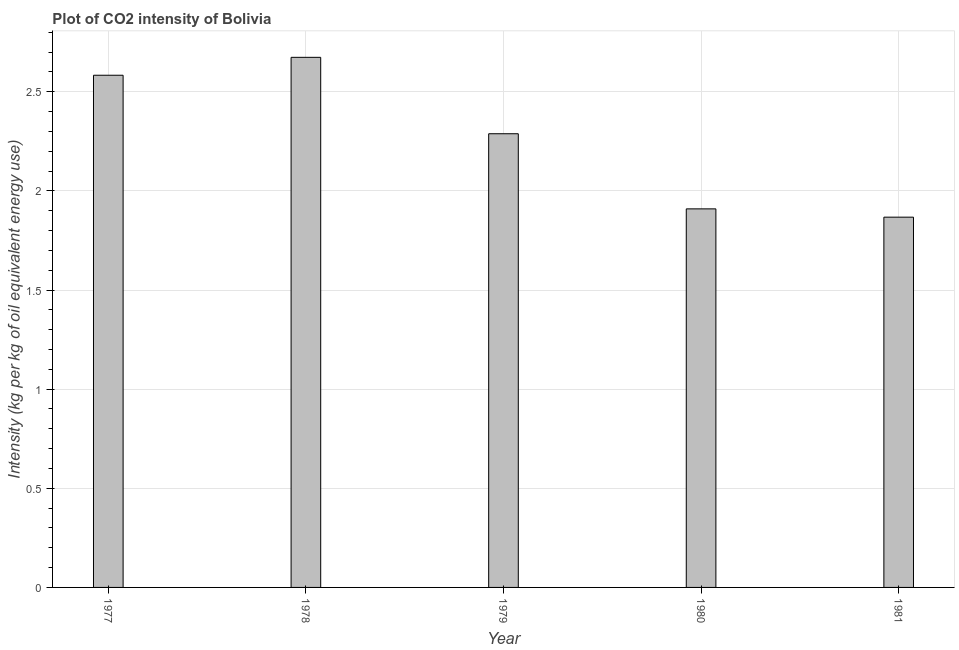Does the graph contain grids?
Offer a very short reply. Yes. What is the title of the graph?
Your response must be concise. Plot of CO2 intensity of Bolivia. What is the label or title of the X-axis?
Provide a succinct answer. Year. What is the label or title of the Y-axis?
Your response must be concise. Intensity (kg per kg of oil equivalent energy use). What is the co2 intensity in 1980?
Provide a succinct answer. 1.91. Across all years, what is the maximum co2 intensity?
Make the answer very short. 2.67. Across all years, what is the minimum co2 intensity?
Give a very brief answer. 1.87. In which year was the co2 intensity maximum?
Offer a very short reply. 1978. What is the sum of the co2 intensity?
Ensure brevity in your answer.  11.32. What is the difference between the co2 intensity in 1978 and 1979?
Your response must be concise. 0.39. What is the average co2 intensity per year?
Offer a terse response. 2.26. What is the median co2 intensity?
Offer a very short reply. 2.29. Do a majority of the years between 1980 and 1978 (inclusive) have co2 intensity greater than 1.6 kg?
Your response must be concise. Yes. What is the ratio of the co2 intensity in 1979 to that in 1980?
Your answer should be very brief. 1.2. Is the difference between the co2 intensity in 1977 and 1978 greater than the difference between any two years?
Provide a short and direct response. No. What is the difference between the highest and the second highest co2 intensity?
Offer a very short reply. 0.09. What is the difference between the highest and the lowest co2 intensity?
Your answer should be compact. 0.81. In how many years, is the co2 intensity greater than the average co2 intensity taken over all years?
Provide a succinct answer. 3. How many years are there in the graph?
Give a very brief answer. 5. What is the difference between two consecutive major ticks on the Y-axis?
Provide a succinct answer. 0.5. What is the Intensity (kg per kg of oil equivalent energy use) in 1977?
Provide a succinct answer. 2.58. What is the Intensity (kg per kg of oil equivalent energy use) of 1978?
Your answer should be compact. 2.67. What is the Intensity (kg per kg of oil equivalent energy use) in 1979?
Offer a terse response. 2.29. What is the Intensity (kg per kg of oil equivalent energy use) of 1980?
Provide a short and direct response. 1.91. What is the Intensity (kg per kg of oil equivalent energy use) of 1981?
Your response must be concise. 1.87. What is the difference between the Intensity (kg per kg of oil equivalent energy use) in 1977 and 1978?
Offer a very short reply. -0.09. What is the difference between the Intensity (kg per kg of oil equivalent energy use) in 1977 and 1979?
Your answer should be very brief. 0.3. What is the difference between the Intensity (kg per kg of oil equivalent energy use) in 1977 and 1980?
Offer a terse response. 0.67. What is the difference between the Intensity (kg per kg of oil equivalent energy use) in 1977 and 1981?
Offer a very short reply. 0.72. What is the difference between the Intensity (kg per kg of oil equivalent energy use) in 1978 and 1979?
Your answer should be very brief. 0.39. What is the difference between the Intensity (kg per kg of oil equivalent energy use) in 1978 and 1980?
Make the answer very short. 0.76. What is the difference between the Intensity (kg per kg of oil equivalent energy use) in 1978 and 1981?
Keep it short and to the point. 0.81. What is the difference between the Intensity (kg per kg of oil equivalent energy use) in 1979 and 1980?
Provide a succinct answer. 0.38. What is the difference between the Intensity (kg per kg of oil equivalent energy use) in 1979 and 1981?
Offer a terse response. 0.42. What is the difference between the Intensity (kg per kg of oil equivalent energy use) in 1980 and 1981?
Provide a succinct answer. 0.04. What is the ratio of the Intensity (kg per kg of oil equivalent energy use) in 1977 to that in 1978?
Keep it short and to the point. 0.97. What is the ratio of the Intensity (kg per kg of oil equivalent energy use) in 1977 to that in 1979?
Give a very brief answer. 1.13. What is the ratio of the Intensity (kg per kg of oil equivalent energy use) in 1977 to that in 1980?
Your answer should be compact. 1.35. What is the ratio of the Intensity (kg per kg of oil equivalent energy use) in 1977 to that in 1981?
Give a very brief answer. 1.38. What is the ratio of the Intensity (kg per kg of oil equivalent energy use) in 1978 to that in 1979?
Your answer should be compact. 1.17. What is the ratio of the Intensity (kg per kg of oil equivalent energy use) in 1978 to that in 1980?
Offer a very short reply. 1.4. What is the ratio of the Intensity (kg per kg of oil equivalent energy use) in 1978 to that in 1981?
Your response must be concise. 1.43. What is the ratio of the Intensity (kg per kg of oil equivalent energy use) in 1979 to that in 1980?
Your answer should be compact. 1.2. What is the ratio of the Intensity (kg per kg of oil equivalent energy use) in 1979 to that in 1981?
Provide a succinct answer. 1.23. 